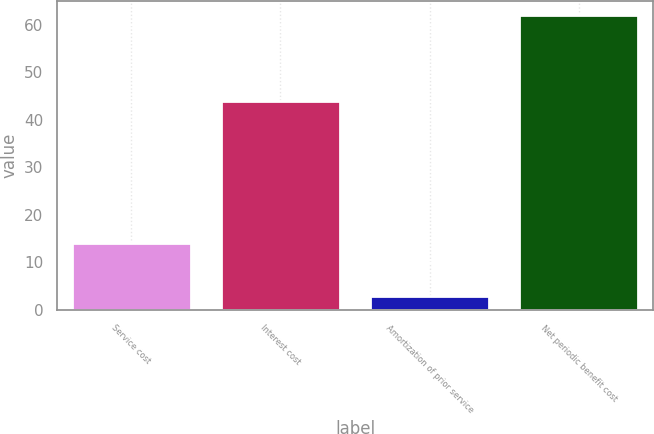Convert chart. <chart><loc_0><loc_0><loc_500><loc_500><bar_chart><fcel>Service cost<fcel>Interest cost<fcel>Amortization of prior service<fcel>Net periodic benefit cost<nl><fcel>14<fcel>44<fcel>3<fcel>62<nl></chart> 